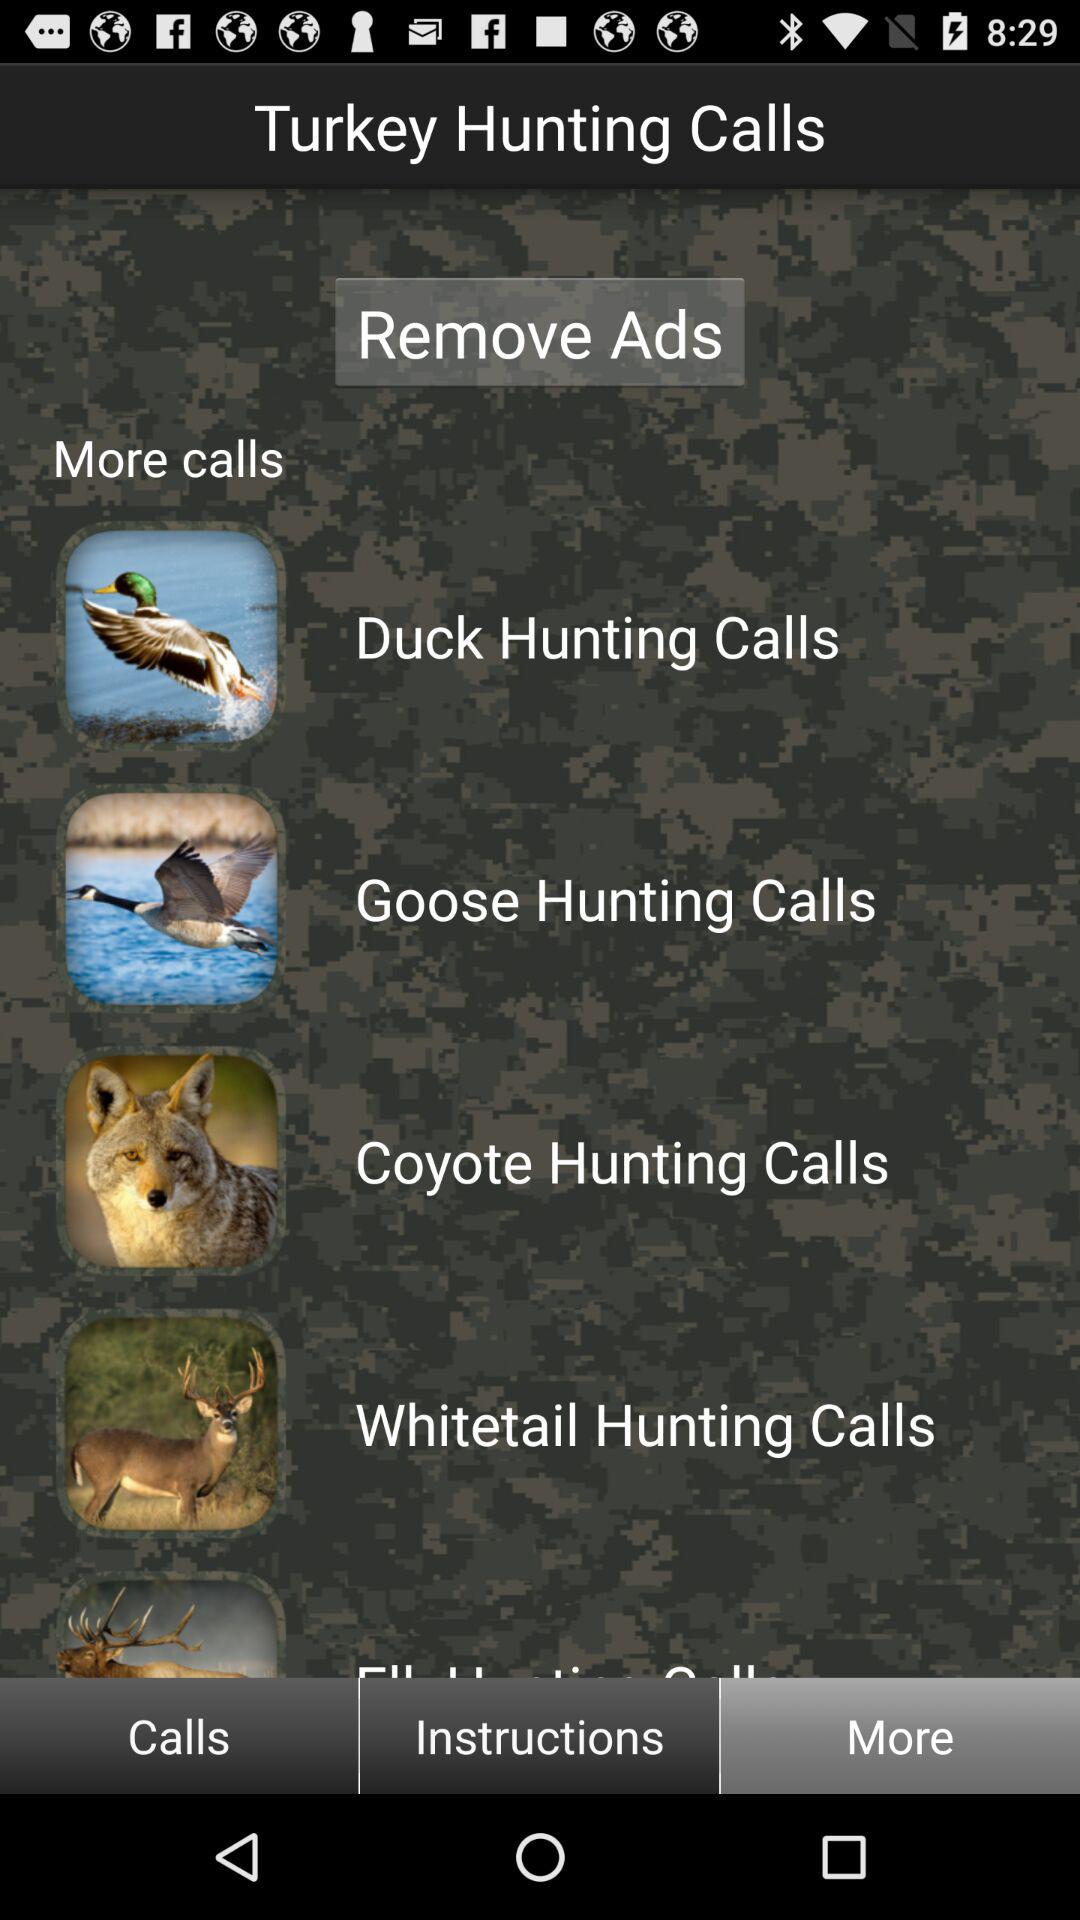Which tab has been selected? The selected tab is "More". 